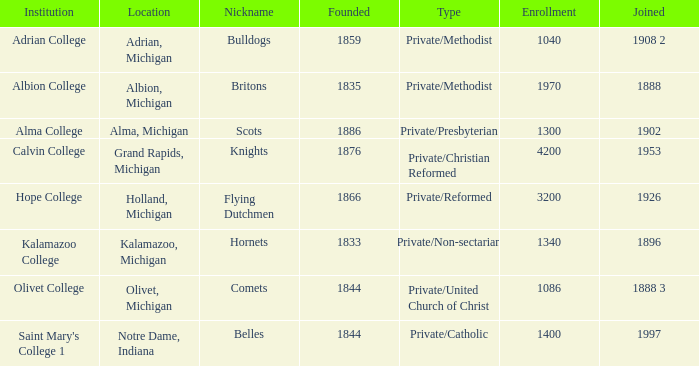Which is the most likely created under belles? 1844.0. 